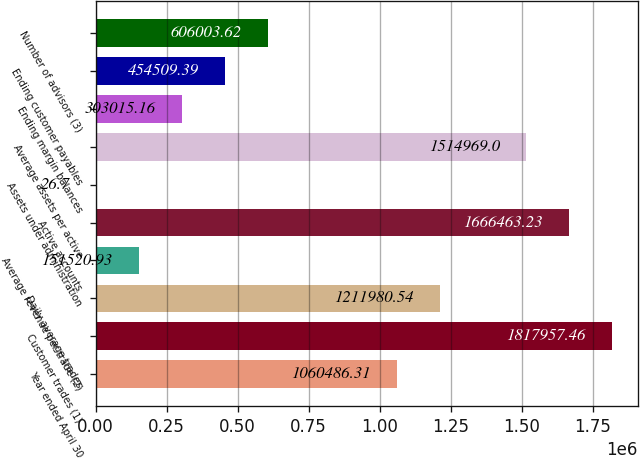Convert chart. <chart><loc_0><loc_0><loc_500><loc_500><bar_chart><fcel>Year ended April 30<fcel>Customer trades (1)<fcel>Daily average trades<fcel>Average revenue per trade (2)<fcel>Active accounts<fcel>Assets under administration<fcel>Average assets per active<fcel>Ending margin balances<fcel>Ending customer payables<fcel>Number of advisors (3)<nl><fcel>1.06049e+06<fcel>1.81796e+06<fcel>1.21198e+06<fcel>151521<fcel>1.66646e+06<fcel>26.7<fcel>1.51497e+06<fcel>303015<fcel>454509<fcel>606004<nl></chart> 